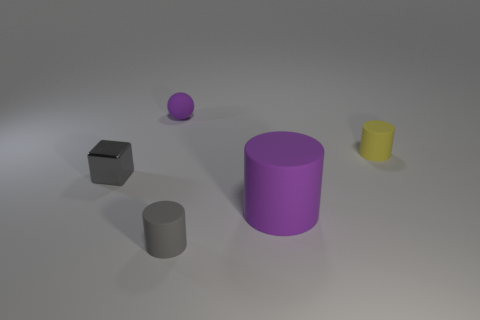How many cubes are either shiny things or tiny matte objects?
Ensure brevity in your answer.  1. There is a thing in front of the purple matte thing on the right side of the tiny ball; what is its shape?
Your answer should be very brief. Cylinder. What size is the purple thing that is to the left of the tiny gray object that is right of the purple object behind the small yellow cylinder?
Give a very brief answer. Small. Is the size of the yellow cylinder the same as the purple cylinder?
Provide a succinct answer. No. How many things are either gray spheres or small spheres?
Give a very brief answer. 1. There is a purple thing behind the tiny gray metal block that is to the left of the small purple rubber sphere; what is its size?
Offer a terse response. Small. What size is the purple ball?
Provide a short and direct response. Small. There is a small object that is right of the tiny metallic block and in front of the yellow rubber object; what is its shape?
Your response must be concise. Cylinder. What color is the other big object that is the same shape as the gray rubber thing?
Offer a terse response. Purple. How many objects are either matte cylinders that are on the right side of the small gray rubber cylinder or objects right of the small gray metal cube?
Offer a terse response. 4. 